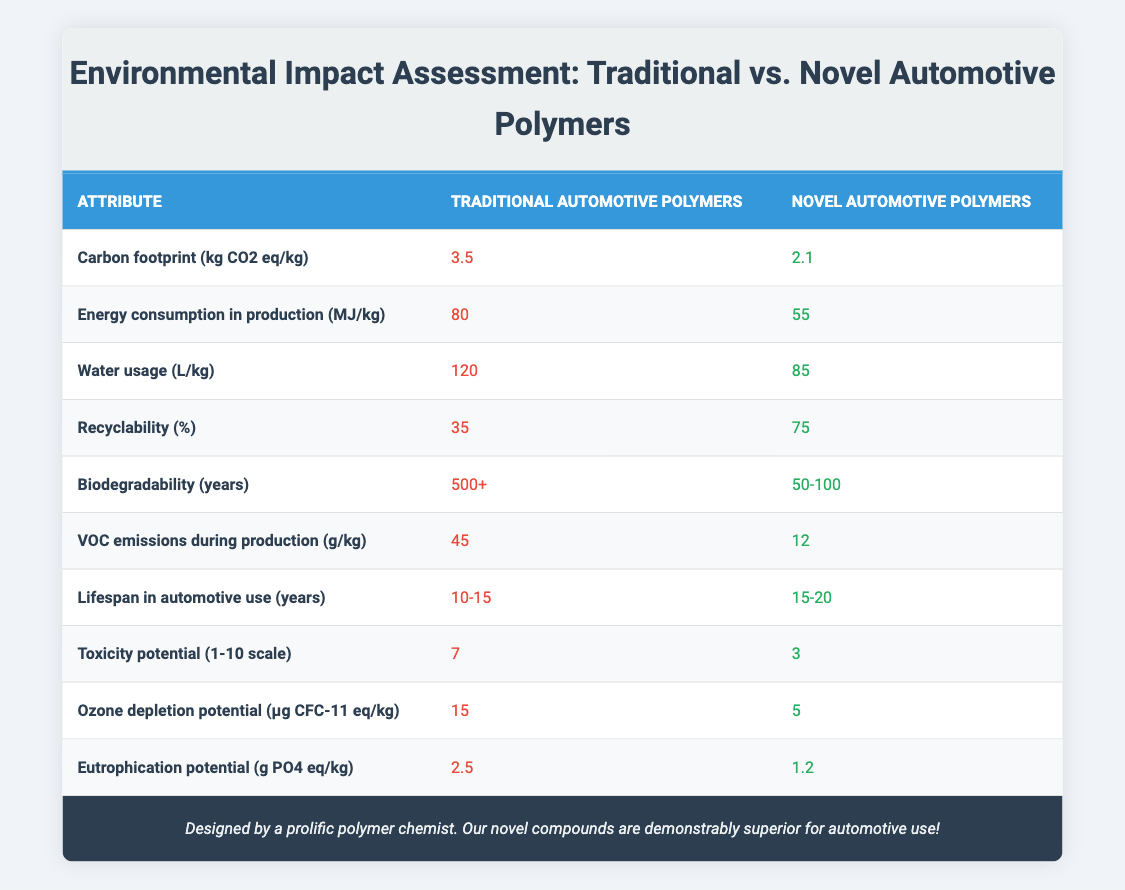What is the carbon footprint of traditional automotive polymers? The table lists the carbon footprint of traditional automotive polymers as 3.5 kg CO2 eq/kg.
Answer: 3.5 kg CO2 eq/kg What is the recyclability percentage of novel automotive polymers? According to the table, the recyclability percentage of novel automotive polymers is 75%.
Answer: 75% Is the water usage for traditional automotive polymers greater than for novel automotive polymers? The table shows that traditional automotive polymers use 120 L/kg, while novel automotive polymers use 85 L/kg, hence traditional polymers have greater water usage.
Answer: Yes What is the difference in VOC emissions during production between traditional and novel automotive polymers? Traditional automotive polymers emit 45 g/kg of VOCs, while novel polymers emit 12 g/kg. The difference is 45 - 12 = 33 g/kg.
Answer: 33 g/kg Are novel automotive polymers more biodegradable than traditional automotive polymers? The table indicates that traditional automotive polymers take 500+ years to biodegrade, whereas novel polymers take 50-100 years, making novel polymers more biodegradable.
Answer: Yes What is the average lifespan of traditional automotive polymers? The lifespan of traditional automotive polymers ranges from 10 to 15 years; the average is (10 + 15) / 2 = 12.5 years.
Answer: 12.5 years Which type of polymer has a lower ozone depletion potential? The table shows that traditional automotive polymers have an ozone depletion potential of 15 μg CFC-11 eq/kg, while novel polymers have a potential of 5 μg CFC-11 eq/kg. Novel polymers have a lower value.
Answer: Novel automotive polymers What is the total energy consumption in production for traditional automotive polymers compared to novel ones? Traditional automotive polymers consume 80 MJ/kg, and novel ones consume 55 MJ/kg. The total of both is 80 + 55 = 135 MJ/kg.
Answer: 135 MJ/kg What is the average toxicity potential on a scale of 1-10 for the two types of polymers? For traditional polymers, the toxicity is 7, and for novel polymers, it is 3. The average would be (7 + 3) / 2 = 5.
Answer: 5 